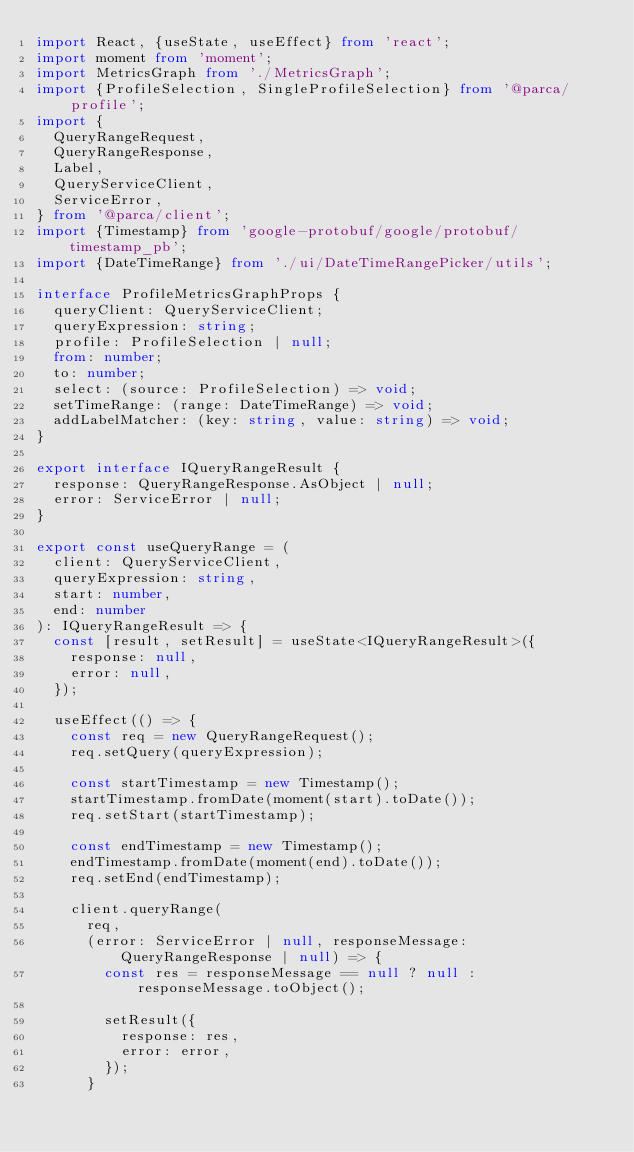Convert code to text. <code><loc_0><loc_0><loc_500><loc_500><_TypeScript_>import React, {useState, useEffect} from 'react';
import moment from 'moment';
import MetricsGraph from './MetricsGraph';
import {ProfileSelection, SingleProfileSelection} from '@parca/profile';
import {
  QueryRangeRequest,
  QueryRangeResponse,
  Label,
  QueryServiceClient,
  ServiceError,
} from '@parca/client';
import {Timestamp} from 'google-protobuf/google/protobuf/timestamp_pb';
import {DateTimeRange} from './ui/DateTimeRangePicker/utils';

interface ProfileMetricsGraphProps {
  queryClient: QueryServiceClient;
  queryExpression: string;
  profile: ProfileSelection | null;
  from: number;
  to: number;
  select: (source: ProfileSelection) => void;
  setTimeRange: (range: DateTimeRange) => void;
  addLabelMatcher: (key: string, value: string) => void;
}

export interface IQueryRangeResult {
  response: QueryRangeResponse.AsObject | null;
  error: ServiceError | null;
}

export const useQueryRange = (
  client: QueryServiceClient,
  queryExpression: string,
  start: number,
  end: number
): IQueryRangeResult => {
  const [result, setResult] = useState<IQueryRangeResult>({
    response: null,
    error: null,
  });

  useEffect(() => {
    const req = new QueryRangeRequest();
    req.setQuery(queryExpression);

    const startTimestamp = new Timestamp();
    startTimestamp.fromDate(moment(start).toDate());
    req.setStart(startTimestamp);

    const endTimestamp = new Timestamp();
    endTimestamp.fromDate(moment(end).toDate());
    req.setEnd(endTimestamp);

    client.queryRange(
      req,
      (error: ServiceError | null, responseMessage: QueryRangeResponse | null) => {
        const res = responseMessage == null ? null : responseMessage.toObject();

        setResult({
          response: res,
          error: error,
        });
      }</code> 